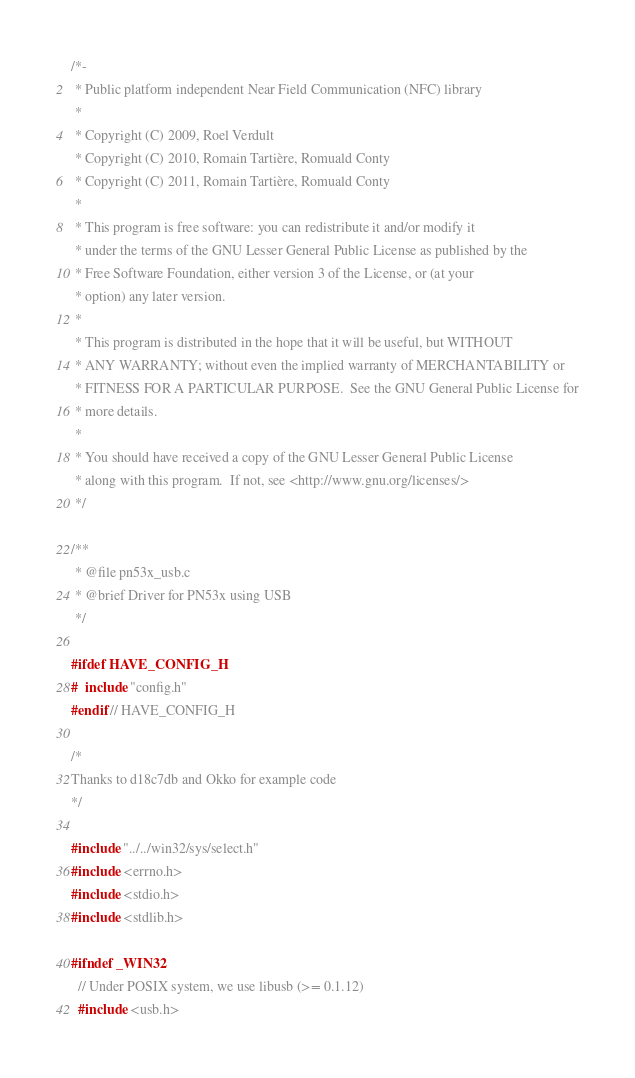Convert code to text. <code><loc_0><loc_0><loc_500><loc_500><_C_>/*-
 * Public platform independent Near Field Communication (NFC) library
 * 
 * Copyright (C) 2009, Roel Verdult
 * Copyright (C) 2010, Romain Tartière, Romuald Conty
 * Copyright (C) 2011, Romain Tartière, Romuald Conty
 * 
 * This program is free software: you can redistribute it and/or modify it
 * under the terms of the GNU Lesser General Public License as published by the
 * Free Software Foundation, either version 3 of the License, or (at your
 * option) any later version.
 * 
 * This program is distributed in the hope that it will be useful, but WITHOUT
 * ANY WARRANTY; without even the implied warranty of MERCHANTABILITY or
 * FITNESS FOR A PARTICULAR PURPOSE.  See the GNU General Public License for
 * more details.
 *
 * You should have received a copy of the GNU Lesser General Public License
 * along with this program.  If not, see <http://www.gnu.org/licenses/>
 */

/**
 * @file pn53x_usb.c
 * @brief Driver for PN53x using USB
 */

#ifdef HAVE_CONFIG_H
#  include "config.h"
#endif // HAVE_CONFIG_H

/*
Thanks to d18c7db and Okko for example code
*/

#include "../../win32/sys/select.h"
#include <errno.h>
#include <stdio.h>
#include <stdlib.h>

#ifndef _WIN32
  // Under POSIX system, we use libusb (>= 0.1.12)
  #include <usb.h></code> 